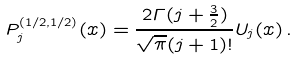<formula> <loc_0><loc_0><loc_500><loc_500>P _ { j } ^ { ( 1 / 2 , 1 / 2 ) } ( x ) = \frac { 2 { \mathit \Gamma } ( j + \frac { 3 } { 2 } ) } { \sqrt { \pi } ( j + 1 ) ! } U _ { j } ( x ) \, .</formula> 